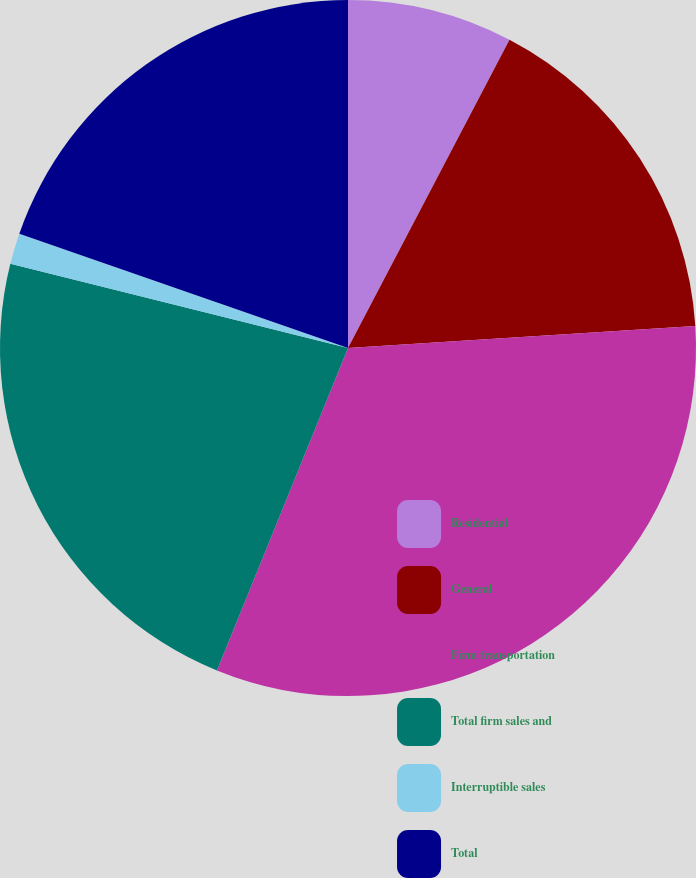<chart> <loc_0><loc_0><loc_500><loc_500><pie_chart><fcel>Residential<fcel>General<fcel>Firm transportation<fcel>Total firm sales and<fcel>Interruptible sales<fcel>Total<nl><fcel>7.68%<fcel>16.31%<fcel>32.15%<fcel>22.74%<fcel>1.44%<fcel>19.67%<nl></chart> 